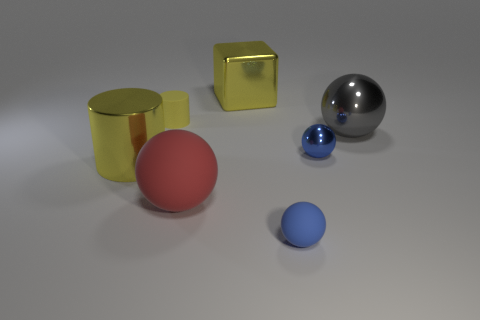Add 3 green metal blocks. How many objects exist? 10 Subtract all brown spheres. Subtract all blue cylinders. How many spheres are left? 4 Subtract all blocks. How many objects are left? 6 Add 4 tiny matte cylinders. How many tiny matte cylinders exist? 5 Subtract 0 blue cylinders. How many objects are left? 7 Subtract all balls. Subtract all yellow objects. How many objects are left? 0 Add 5 small blue shiny objects. How many small blue shiny objects are left? 6 